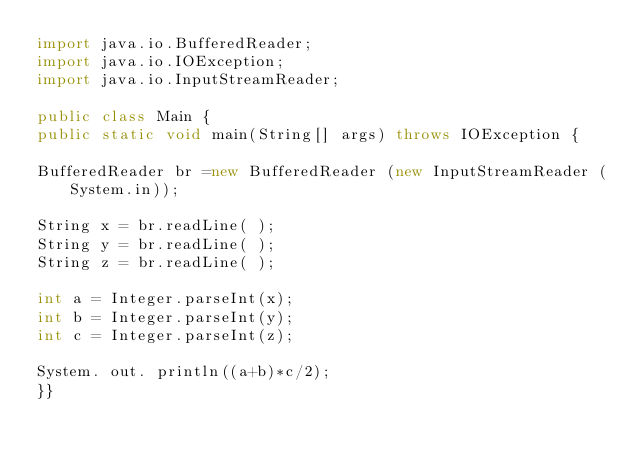<code> <loc_0><loc_0><loc_500><loc_500><_Java_>import java.io.BufferedReader;
import java.io.IOException;
import java.io.InputStreamReader;

public class Main {
public static void main(String[] args) throws IOException {

BufferedReader br =new BufferedReader (new InputStreamReader (System.in));

String x = br.readLine( );
String y = br.readLine( );
String z = br.readLine( );
 
int a = Integer.parseInt(x);
int b = Integer.parseInt(y);
int c = Integer.parseInt(z);

System. out. println((a+b)*c/2);
}}
</code> 